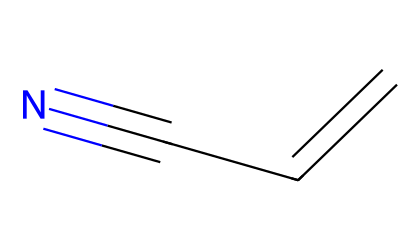What is the molecular formula of acrylonitrile? The structure shows three carbon atoms, three hydrogen atoms, and one nitrogen atom, leading to the molecular formula C3H3N.
Answer: C3H3N How many π bonds are present in acrylonitrile? Examining the structure, there is a double bond between the first two carbon atoms and a triple bond between the second carbon and the nitrogen atom, totaling 2 π bonds.
Answer: 2 What type of functional group is present in acrylonitrile? The nitrile group is characterized by a carbon atom triple-bonded to a nitrogen atom, which is evident in the chemical structure provided.
Answer: nitrile What is the hybridization of the carbon atoms in acrylonitrile? The first carbon is sp2 hybridized due to the double bond, and the second and third carbons are sp hybridized because of the triple bond with nitrogen, resulting in a mix of sp2 and sp hybridization.
Answer: sp2 and sp What is the total number of atoms in acrylonitrile? By counting, there are 3 carbon atoms, 3 hydrogen atoms, and 1 nitrogen atom, which sums to a total of 7 atoms.
Answer: 7 Is acrylonitrile considered a stable compound? While acrylonitrile is stable under standard conditions, it can undergo polymerization or reactions with nucleophiles, indicating it possesses certain reactivity.
Answer: stable with exceptions 